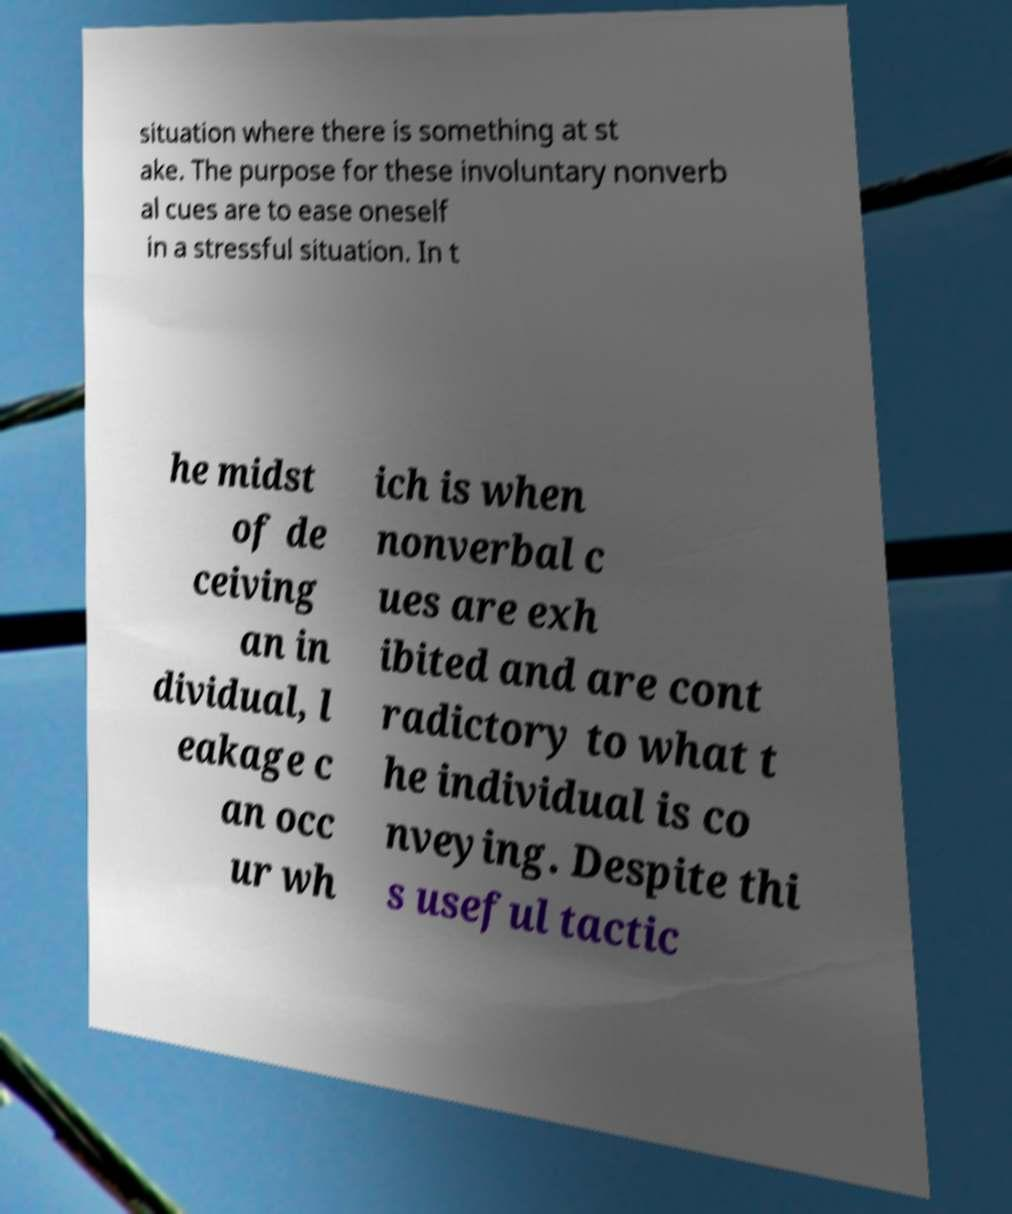There's text embedded in this image that I need extracted. Can you transcribe it verbatim? situation where there is something at st ake. The purpose for these involuntary nonverb al cues are to ease oneself in a stressful situation. In t he midst of de ceiving an in dividual, l eakage c an occ ur wh ich is when nonverbal c ues are exh ibited and are cont radictory to what t he individual is co nveying. Despite thi s useful tactic 